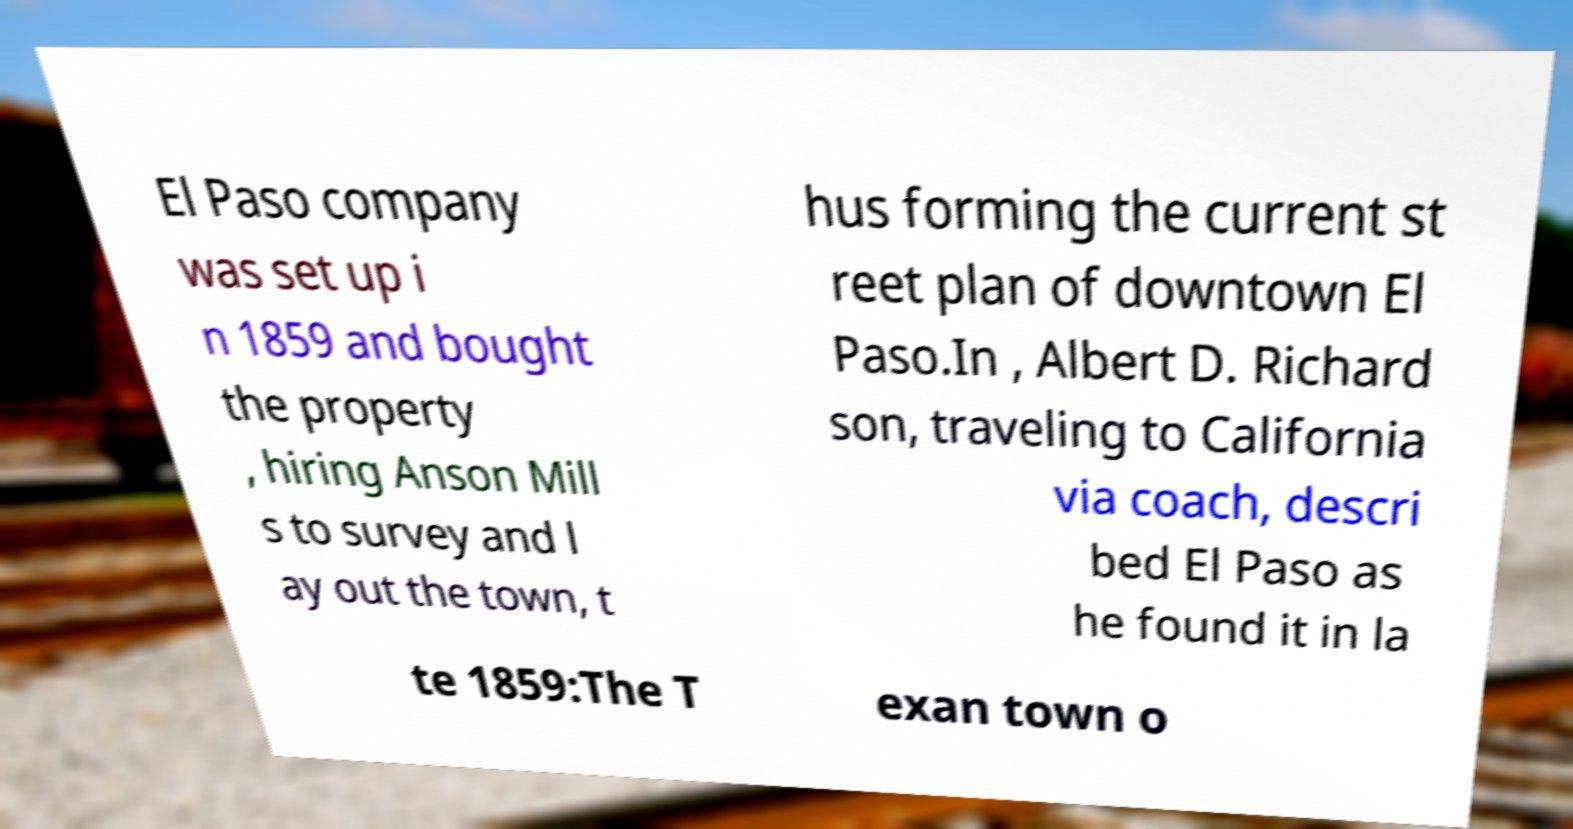Can you accurately transcribe the text from the provided image for me? El Paso company was set up i n 1859 and bought the property , hiring Anson Mill s to survey and l ay out the town, t hus forming the current st reet plan of downtown El Paso.In , Albert D. Richard son, traveling to California via coach, descri bed El Paso as he found it in la te 1859:The T exan town o 